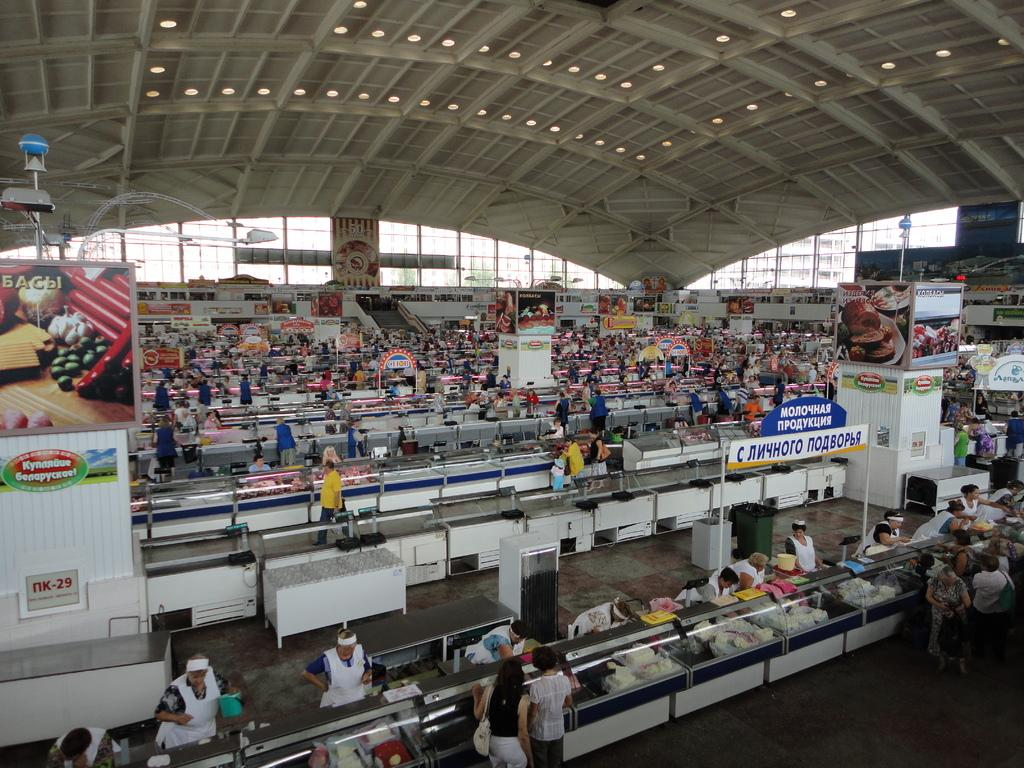Where was the image taken? The image was taken inside a supermarket. Can you describe the scene in the image? There are many people in the image. Are there any ghosts visible in the image? No, there are no ghosts present in the image. What type of weather can be seen through the windows in the image? There are no windows visible in the image, as it was taken inside a supermarket. 